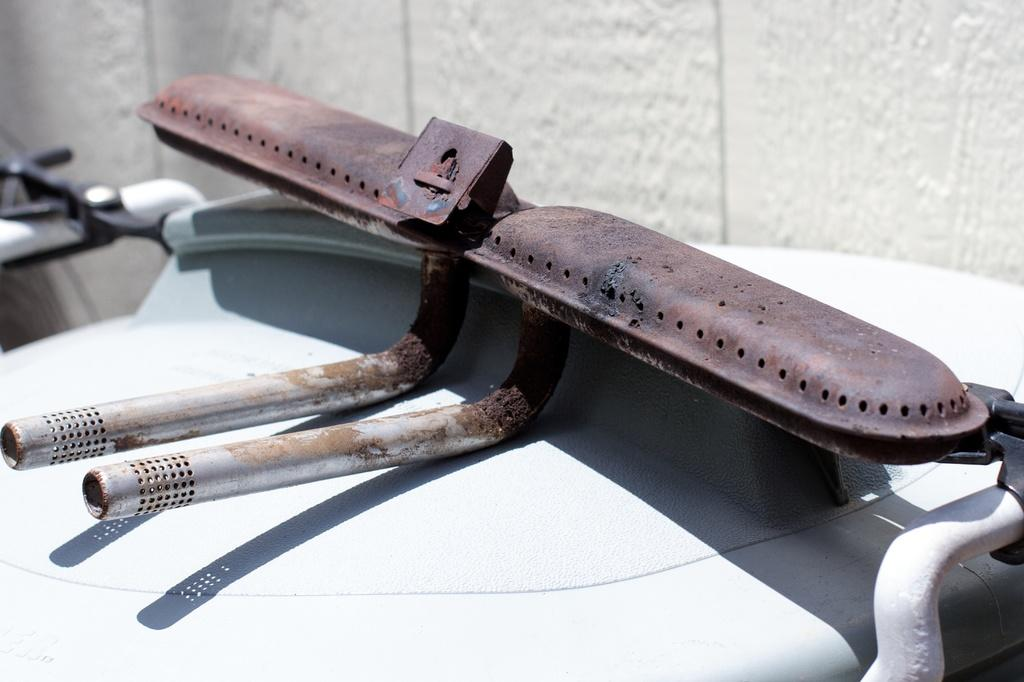What type of tool is in the image? There is an iron instrument in the image. What is the iron instrument placed on? The iron instrument is placed on a white object. Can you describe the condition of the iron instrument? The iron instrument has rust on it. What can be seen in the background of the image? There is a wall in the image. What type of scent is emitted by the iron instrument in the image? The iron instrument does not emit a scent in the image. 